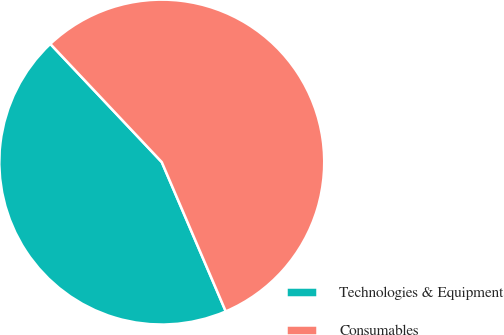<chart> <loc_0><loc_0><loc_500><loc_500><pie_chart><fcel>Technologies & Equipment<fcel>Consumables<nl><fcel>44.41%<fcel>55.59%<nl></chart> 